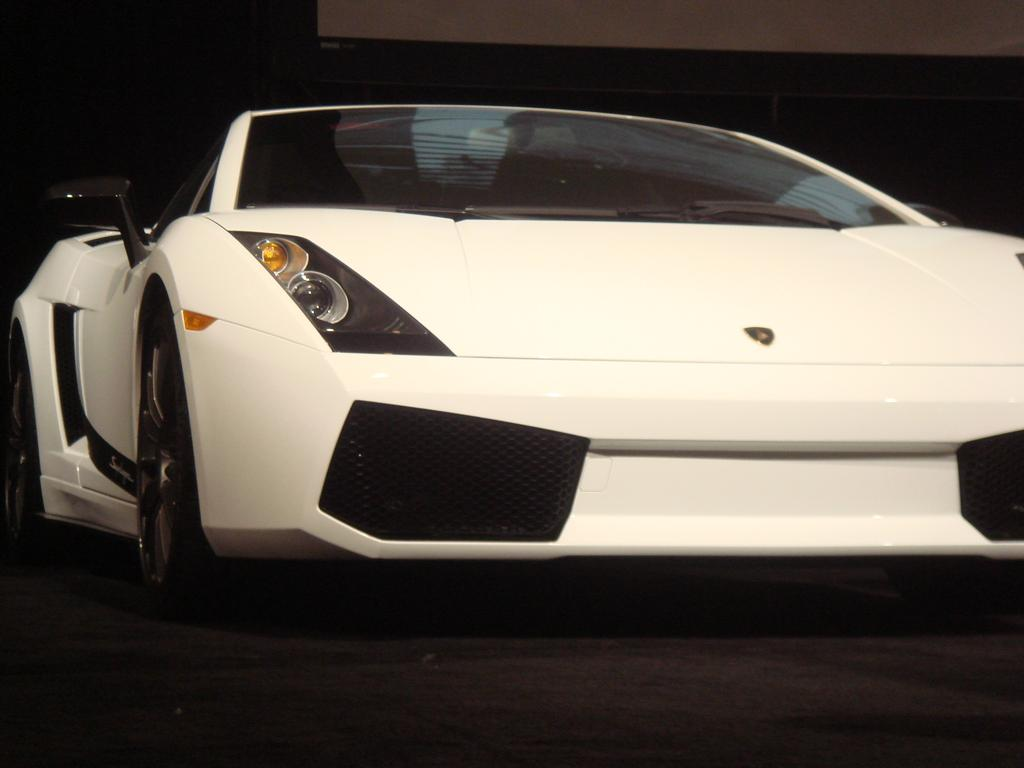What type of vehicle is in the image? There is a white sports car in the image. What can be observed about the color of the background in the image? The background of the image is black. What type of scent is emitted by the sports car in the image? There is no information about the scent of the sports car in the image. --- Facts: 1. There is a person holding a book in the image. 2. The person is sitting on a chair. 3. The chair is made of wood. 4. The book has a red cover. Absurd Topics: parrot, ocean, dance Conversation: What is the person in the image holding? The person is holding a book in the image. What is the person doing while holding the book? The person is sitting on a chair while holding the book. What material is the chair made of? The chair is made of wood. What color is the book's cover? The book has a red cover. Reasoning: Let's think step by step in order to produce the conversation. We start by identifying the main subject in the image, which is the person holding a book. Then, we expand the conversation to include the person's position and the material of the chair. Finally, we mention the color of the book's cover. Each question is designed to elicit a specific detail about the image that is known from the provided facts. Absurd Question/Answer: Can you see any parrots flying over the ocean in the image? There is no mention of parrots or an ocean in the image. 